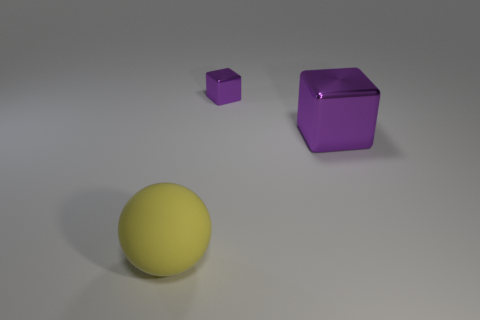Add 2 large purple spheres. How many objects exist? 5 Subtract all big yellow matte objects. Subtract all brown objects. How many objects are left? 2 Add 3 small blocks. How many small blocks are left? 4 Add 2 tiny brown matte blocks. How many tiny brown matte blocks exist? 2 Subtract 2 purple cubes. How many objects are left? 1 Subtract all balls. How many objects are left? 2 